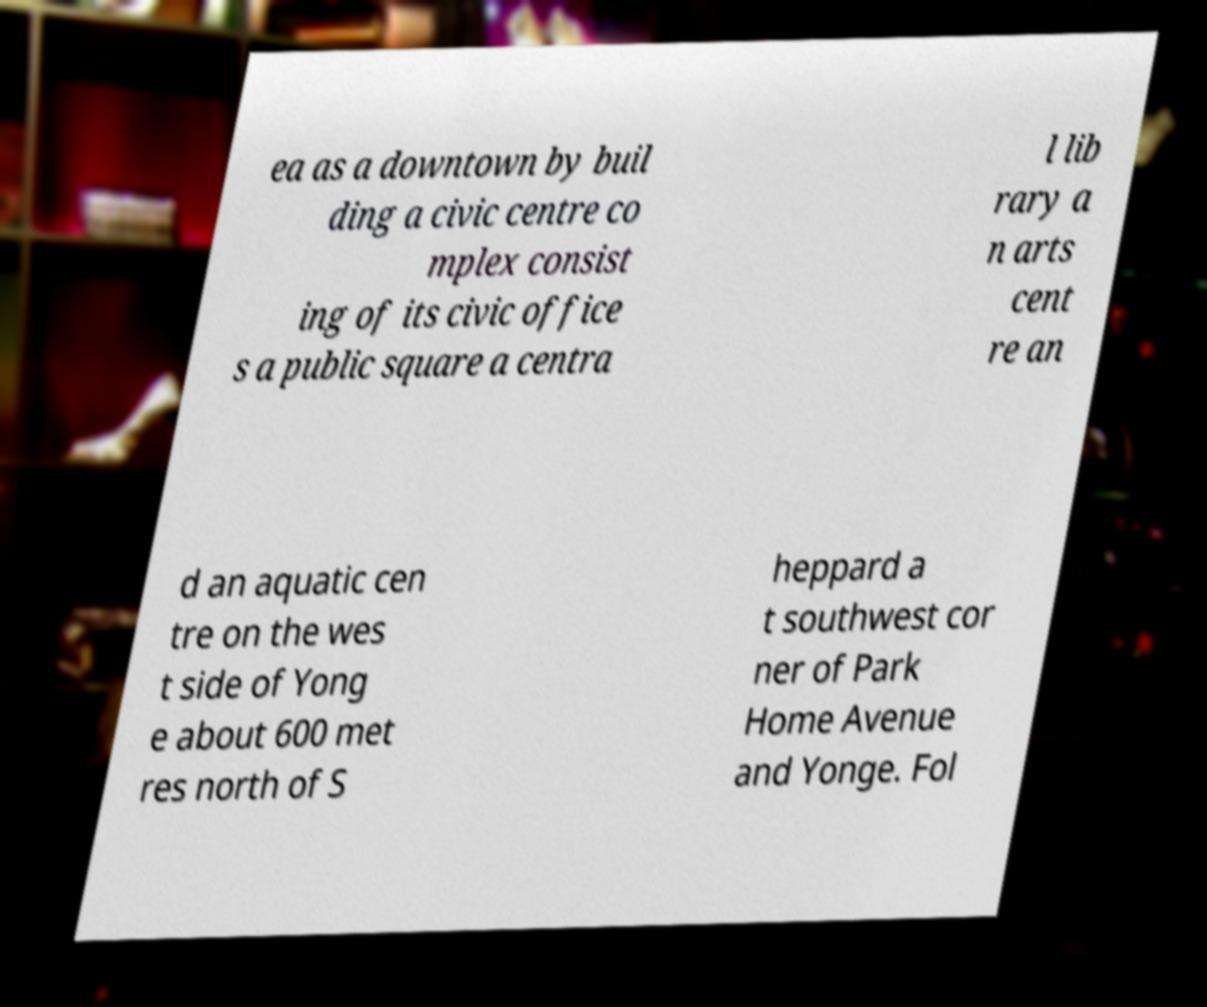Can you read and provide the text displayed in the image?This photo seems to have some interesting text. Can you extract and type it out for me? ea as a downtown by buil ding a civic centre co mplex consist ing of its civic office s a public square a centra l lib rary a n arts cent re an d an aquatic cen tre on the wes t side of Yong e about 600 met res north of S heppard a t southwest cor ner of Park Home Avenue and Yonge. Fol 